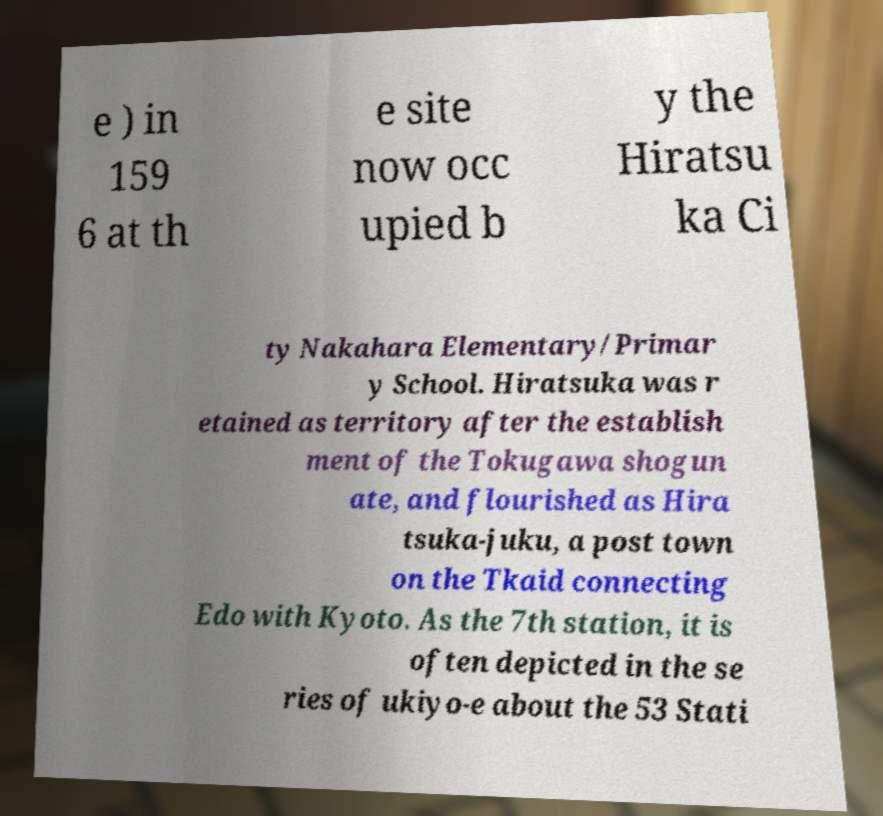I need the written content from this picture converted into text. Can you do that? e ) in 159 6 at th e site now occ upied b y the Hiratsu ka Ci ty Nakahara Elementary/Primar y School. Hiratsuka was r etained as territory after the establish ment of the Tokugawa shogun ate, and flourished as Hira tsuka-juku, a post town on the Tkaid connecting Edo with Kyoto. As the 7th station, it is often depicted in the se ries of ukiyo-e about the 53 Stati 